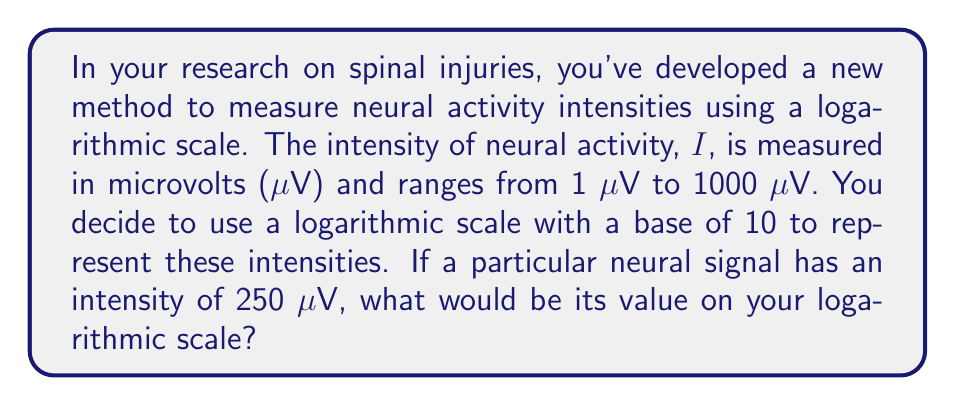Provide a solution to this math problem. To solve this problem, we need to understand how logarithmic scales work and apply the logarithm function. Here's a step-by-step explanation:

1. The general formula for converting a value to a logarithmic scale is:
   $$L = \log_b(\frac{I}{I_0})$$
   Where:
   $L$ is the value on the logarithmic scale
   $b$ is the base of the logarithm (in this case, 10)
   $I$ is the intensity we're measuring
   $I_0$ is the reference intensity (usually the lowest value in the range)

2. In this case:
   $b = 10$
   $I = 250$ μV
   $I_0 = 1$ μV (the lowest value in the range)

3. Substituting these values into the formula:
   $$L = \log_{10}(\frac{250}{1})$$

4. Simplify:
   $$L = \log_{10}(250)$$

5. Using a calculator or logarithm table, we can find that:
   $$L \approx 2.3979$$

6. It's common to round logarithmic scale values to two decimal places, so our final answer would be 2.40.

This scale effectively compresses the wide range of intensities (1 to 1000 μV) into a more manageable range (0 to 3 on the log scale), making it easier to visualize and compare neural activity intensities across different magnitudes.
Answer: 2.40 